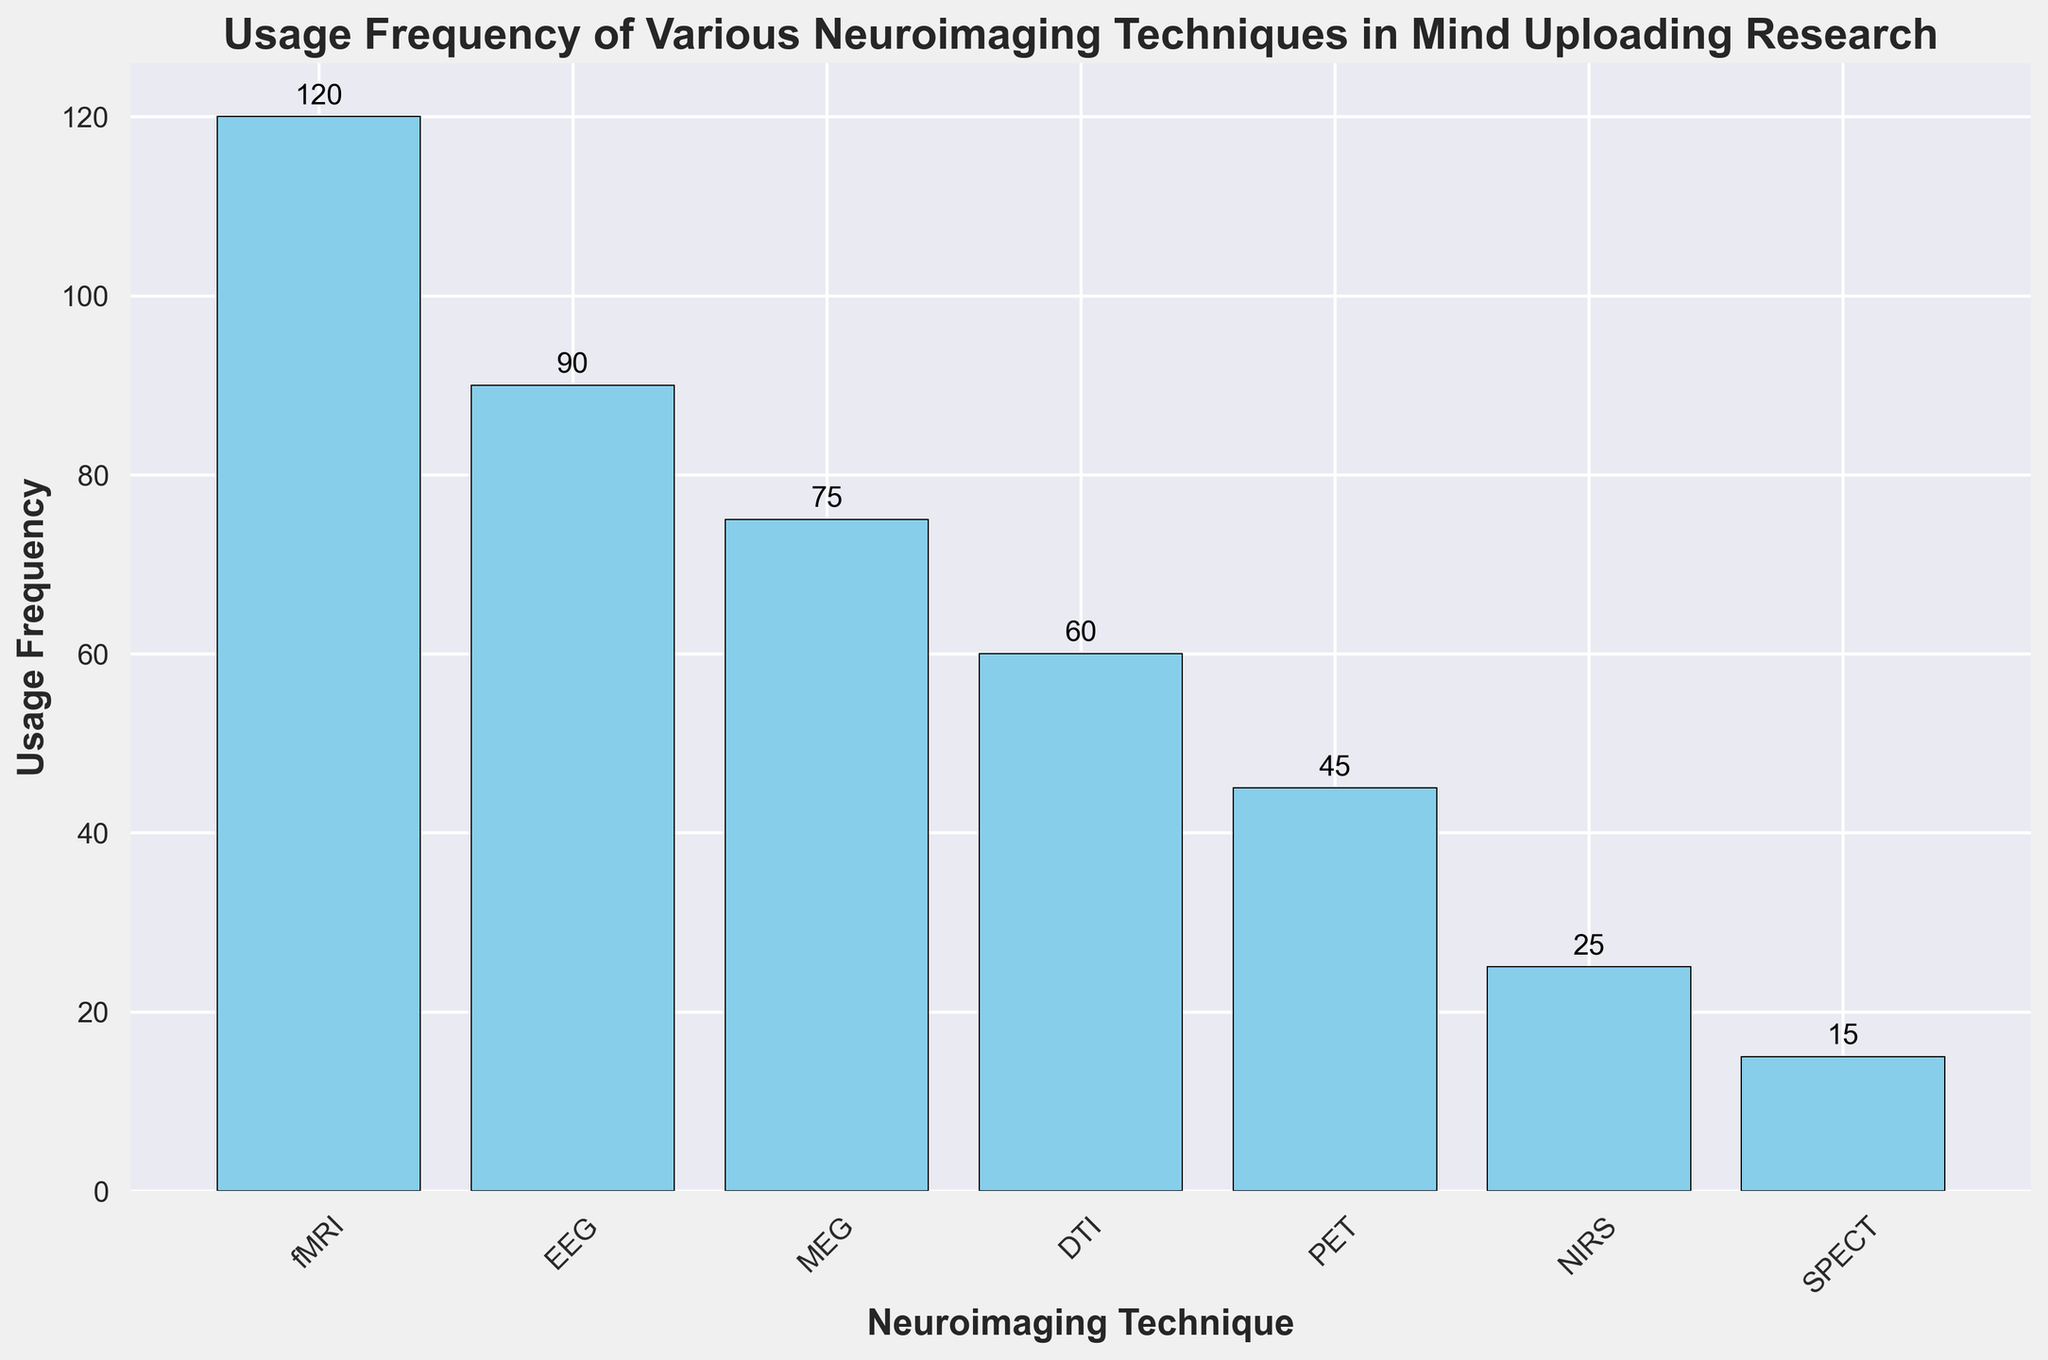Which neuroimaging technique is used the most frequently in mind uploading research? The tallest bar on the chart represents the most frequently used technique. By inspecting the chart, the fMRI technique has the tallest bar with a usage frequency of 120.
Answer: fMRI What is the difference in usage frequency between fMRI and PET? To find the difference, look at the heights of the bars for fMRI and PET. fMRI has a frequency of 120, and PET has a frequency of 45. Subtracting these gives 120 - 45.
Answer: 75 Among EEG, MEG, and DTI, which technique is used the least frequently? Compare the heights of the bars for EEG, MEG, and DTI. EEG has a frequency of 90, MEG has 75, and DTI has 60. The shortest bar among these is for DTI.
Answer: DTI What is the average usage frequency of EEG, MEG, and DTI? Add the usage frequencies of EEG (90), MEG (75), and DTI (60). Then divide the sum by the number of techniques (3). The calculation is (90 + 75 + 60) / 3.
Answer: 75 Is there any technique with a usage frequency less than 20? Check the heights of all bars to see if any have a value below 20. The SPECT technique has a usage frequency of 15, which is less than 20.
Answer: Yes, SPECT How much more frequently is NIRS used compared to SPECT? Look at the values for NIRS and SPECT. NIRS has a frequency of 25, and SPECT has a frequency of 15. Subtracting these gives 25 - 15.
Answer: 10 Which two techniques have the most similar usage frequencies? Compare the bars to find the closest heights. EEG with a frequency of 90 and MEG with 75 are the closest, differing by 15.
Answer: EEG and MEG If you sum the usage frequencies of all techniques except fMRI, what is the total? Add the frequencies of all techniques except fMRI. The calculation is 90 (EEG) + 75 (MEG) + 60 (DTI) + 45 (PET) + 25 (NIRS) + 15 (SPECT). This totals to 310.
Answer: 310 How does the usage frequency of DTI compare to PET? Check the bar heights for DTI and PET. DTI has a frequency of 60, while PET has 45. Therefore, DTI is used more frequently than PET.
Answer: DTI is used more frequently Which technique, among EEG, MEG, DTI, PET, and NIRS, has the second-lowest usage frequency? Compare the bar heights for EEG, MEG, DTI, PET, and NIRS. PET (45) has the lowest, and NIRS (25) has a slightly higher frequency.
Answer: PET 